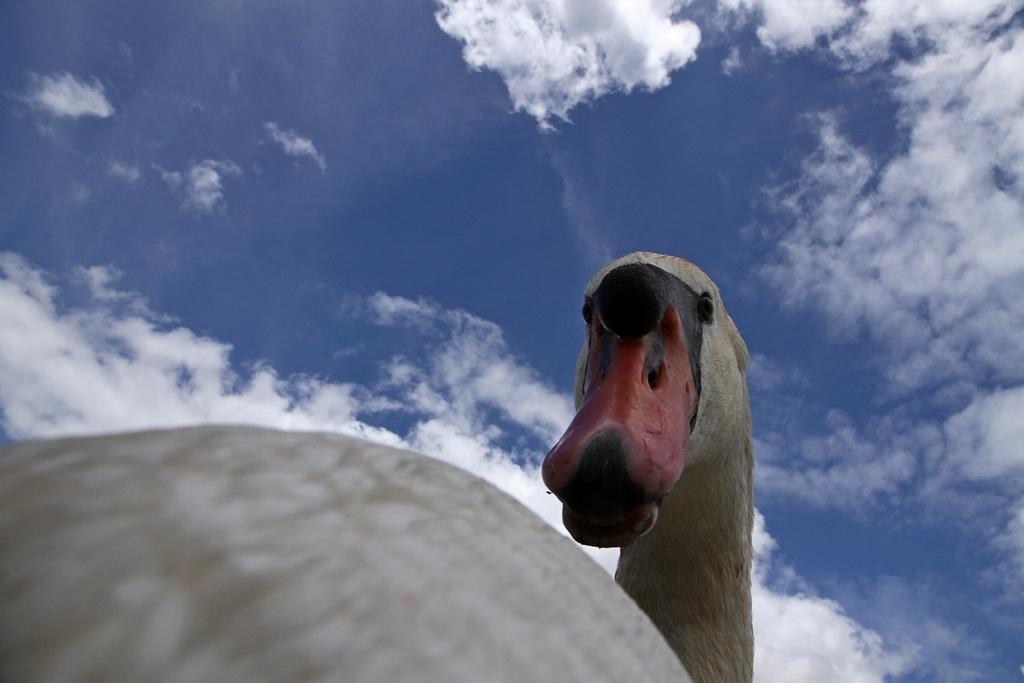Describe this image in one or two sentences. In the picture I can see a bird. In the background I can see the sky. 